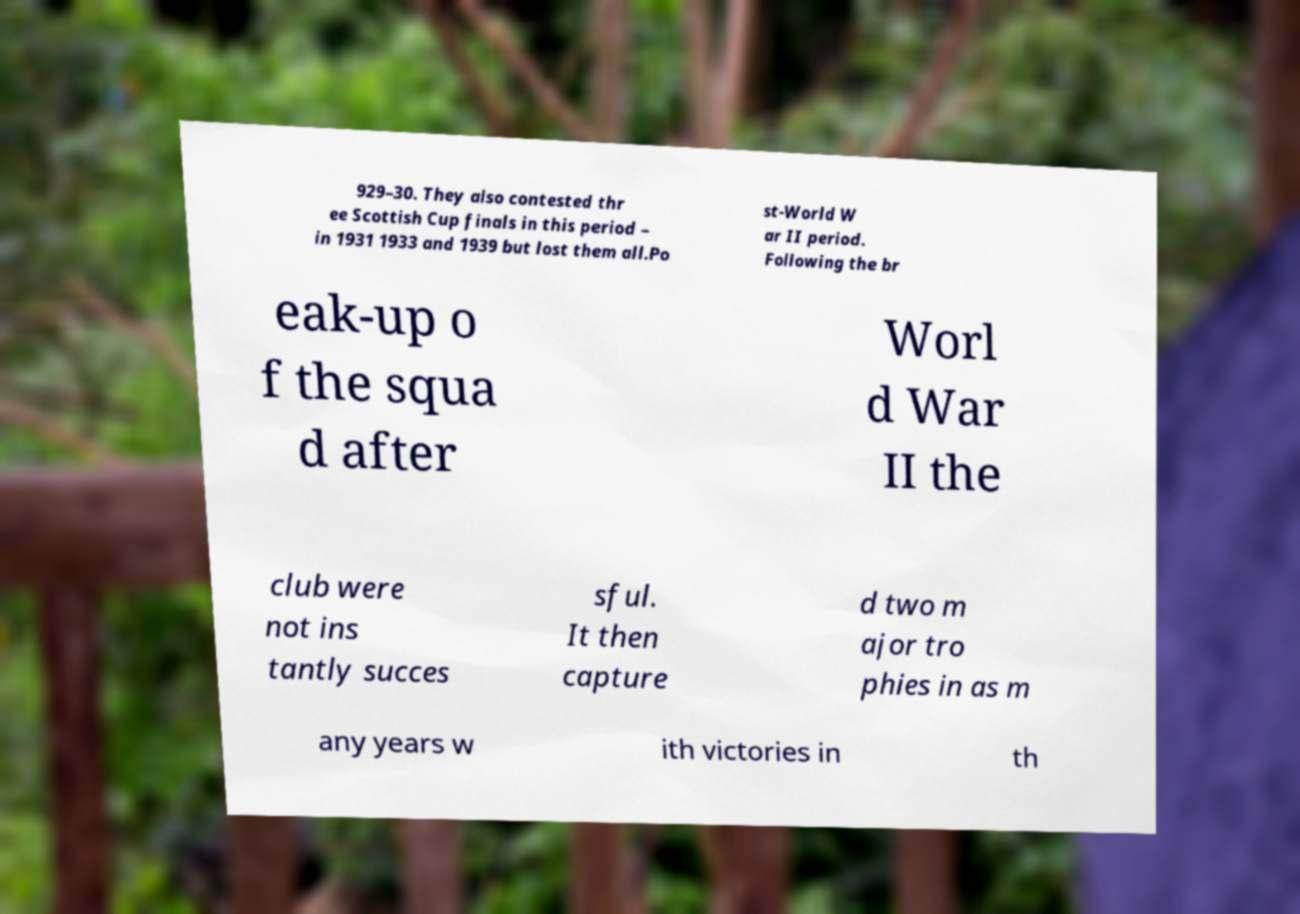Please identify and transcribe the text found in this image. 929–30. They also contested thr ee Scottish Cup finals in this period – in 1931 1933 and 1939 but lost them all.Po st-World W ar II period. Following the br eak-up o f the squa d after Worl d War II the club were not ins tantly succes sful. It then capture d two m ajor tro phies in as m any years w ith victories in th 